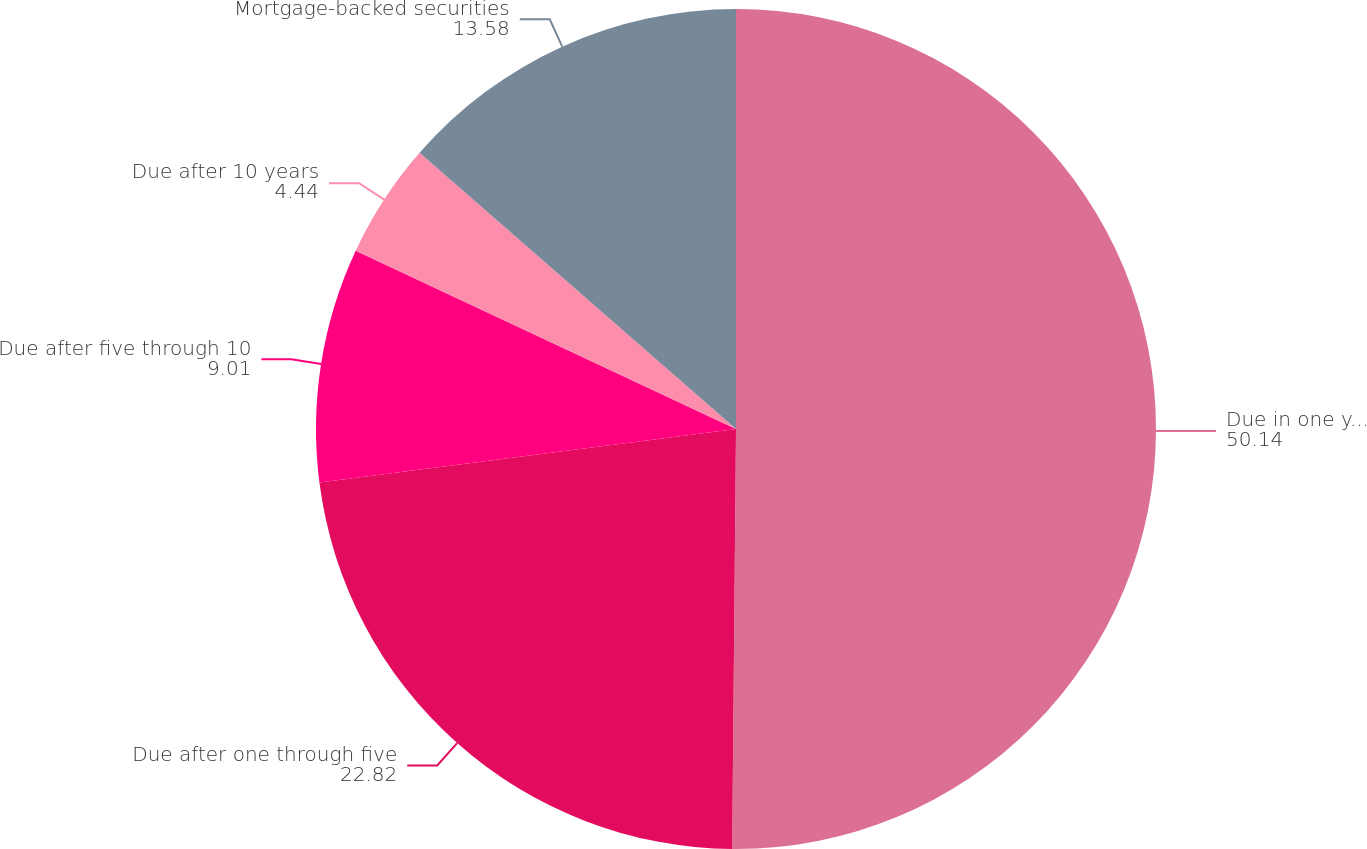<chart> <loc_0><loc_0><loc_500><loc_500><pie_chart><fcel>Due in one year or less<fcel>Due after one through five<fcel>Due after five through 10<fcel>Due after 10 years<fcel>Mortgage-backed securities<nl><fcel>50.14%<fcel>22.82%<fcel>9.01%<fcel>4.44%<fcel>13.58%<nl></chart> 